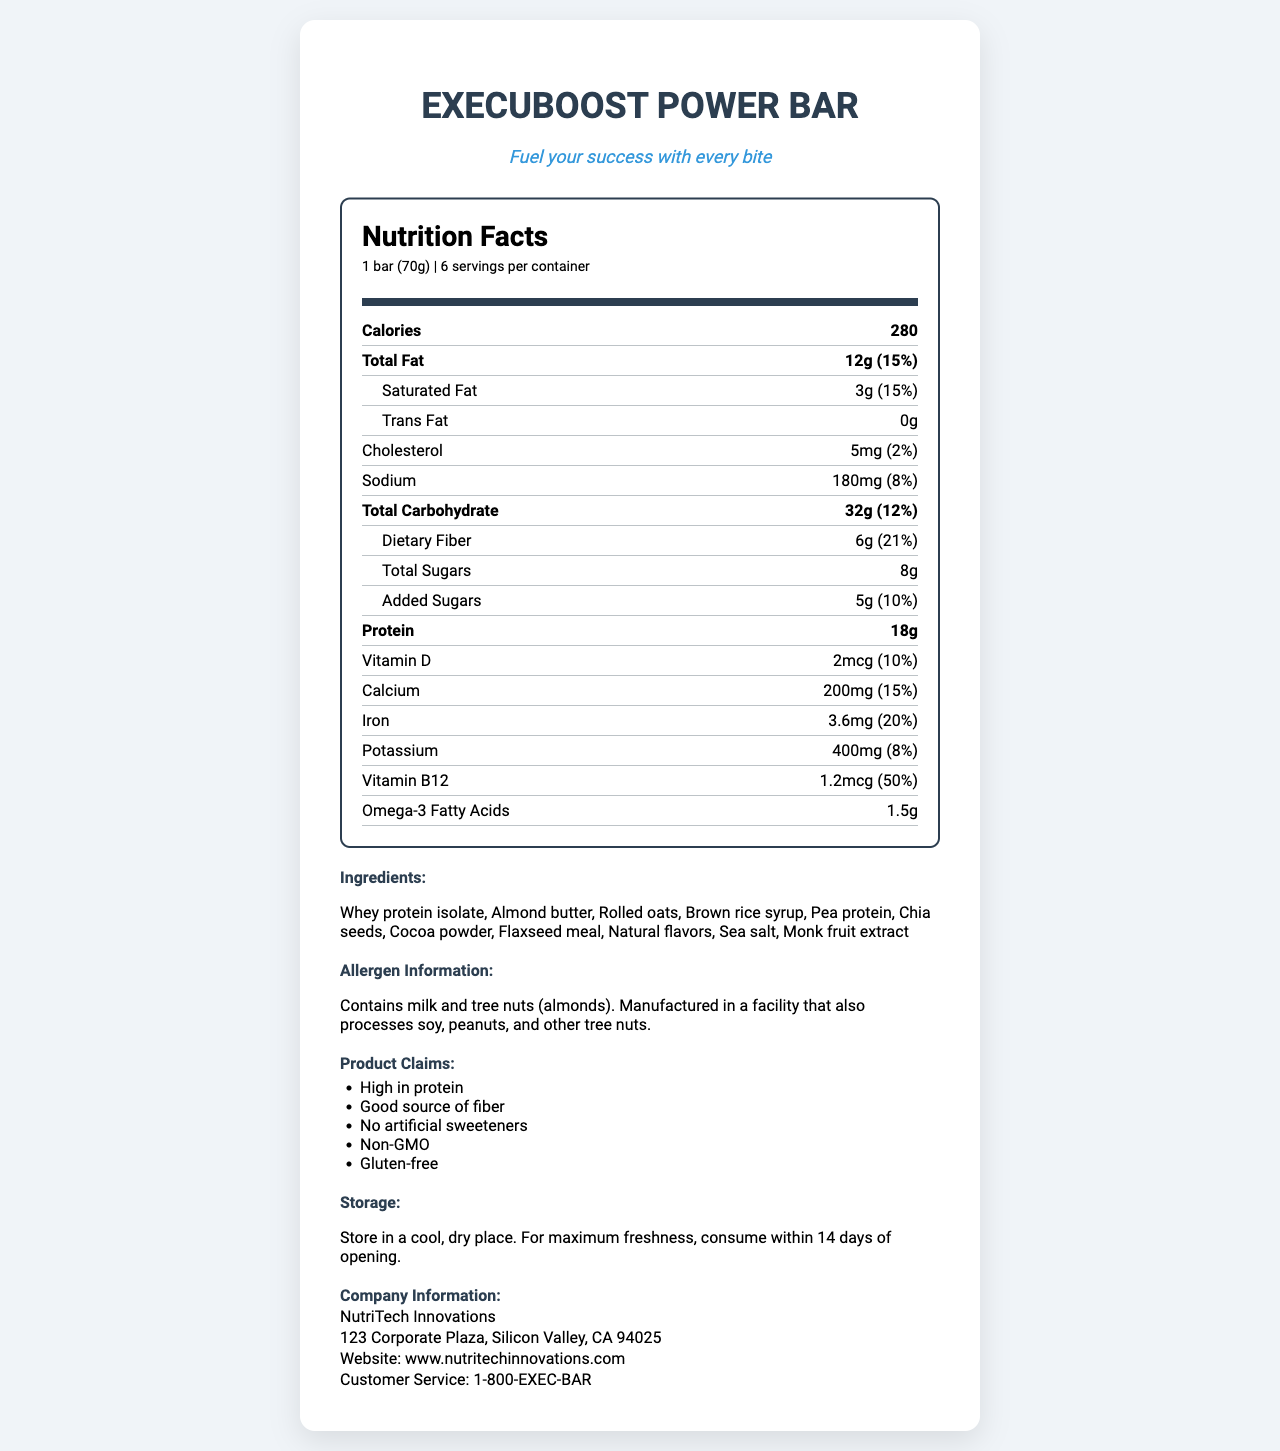What is the serving size for the ExecuBoost Power Bar? The serving size information is stated under the nutrition facts header.
Answer: 1 bar (70g) How many calories are in one serving of the ExecuBoost Power Bar? The number of calories per serving is clearly listed as 280.
Answer: 280 calories What is the total fat content per serving? The nutrition label indicates that the total fat content per serving is 12 grams.
Answer: 12g How much dietary fiber does one serving of the ExecuBoost Power Bar contain? The dietary fiber content per serving is listed as 6 grams.
Answer: 6g What percentage of the daily value for vitamin B12 does the ExecuBoost Power Bar provide? The document mentions that one serving contains 50% of the daily value for vitamin B12.
Answer: 50% Which ingredient in the ExecuBoost Power Bar contains an allergen? The allergen information section lists "tree nuts (almonds)" as an allergen, and almond butter contains almonds.
Answer: Almond butter Which of the following is NOT listed as a claim for the ExecuBoost Power Bar? A. Gluten-free B. Low-calorie C. Non-GMO The claims listed are High in protein, Good source of fiber, No artificial sweeteners, Non-GMO, and Gluten-free. "Low-calorie" is not listed.
Answer: B How much protein does one serving of the ExecuBoost Power Bar contain? The document lists the protein content as 18 grams per serving.
Answer: 18g How long should the ExecuBoost Power Bar be consumed within for maximum freshness? The storage section states to consume within 14 days of opening for maximum freshness.
Answer: 14 days of opening What is the amount of cholesterol in one bar? The document lists the cholesterol content as 5 milligrams per serving.
Answer: 5mg Out of the following vitamins and minerals, which one has the highest percentage of daily value provided by the bar? A. Vitamin D B. Calcium C. Iron D. Potassium Iron provides 20% of the daily value, which is higher than vitamin D (10%), calcium (15%), and potassium (8%).
Answer: C. Iron Does the ExecuBoost Power Bar contain any trans fat? The document lists the trans fat content as 0 grams.
Answer: No Summarize the main nutritional benefits and claims of the ExecuBoost Power Bar. The document highlights the nutritional benefits, such as high protein and fiber content, alongside key vitamins and minerals. It also lists claims emphasizing the product's health benefits and absence of artificial additives.
Answer: The ExecuBoost Power Bar is a nutrient-dense meal replacement bar designed for busy executives, providing 280 calories, 18 grams of protein, 6 grams of dietary fiber, and essential vitamins and minerals like calcium, iron, and vitamin B12. It is high in protein, a good source of fiber, contains no artificial sweeteners, is Non-GMO, and gluten-free. What is the shelf-life of the ExecuBoost Power Bar prior to opening? The document specifies that it should be consumed within 14 days of opening but doesn't provide information on the shelf-life prior to opening.
Answer: Not enough information 